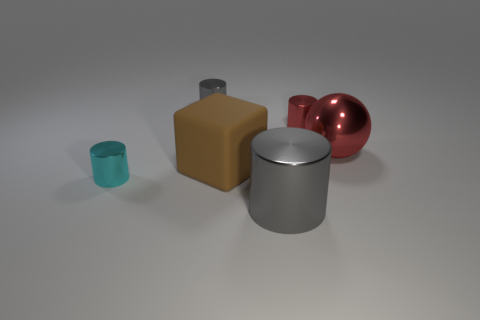Subtract all gray blocks. Subtract all brown balls. How many blocks are left? 1 Add 3 red metal balls. How many objects exist? 9 Subtract all cubes. How many objects are left? 5 Subtract all big cyan rubber balls. Subtract all big gray shiny things. How many objects are left? 5 Add 6 red shiny spheres. How many red shiny spheres are left? 7 Add 6 gray metal things. How many gray metal things exist? 8 Subtract 2 gray cylinders. How many objects are left? 4 